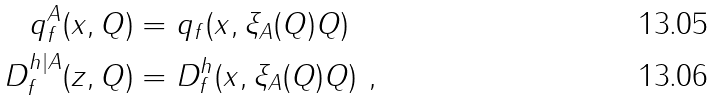<formula> <loc_0><loc_0><loc_500><loc_500>q ^ { A } _ { f } ( x , Q ) & = q _ { f } ( x , \xi _ { A } ( Q ) Q ) \\ D ^ { h | A } _ { f } ( z , Q ) & = D ^ { h } _ { f } ( x , \xi _ { A } ( Q ) Q ) \ ,</formula> 